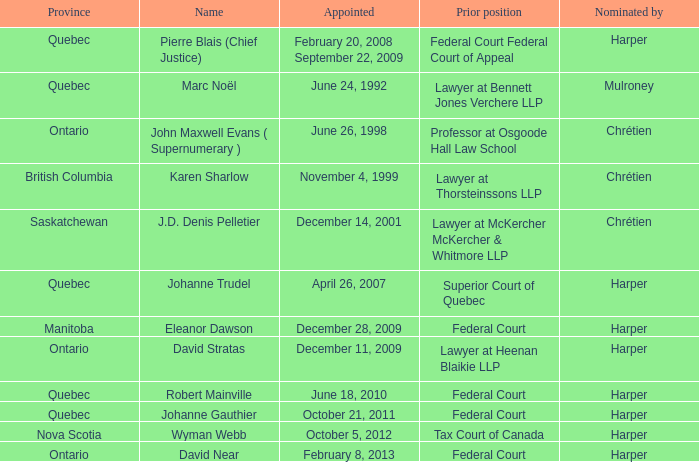What was the prior position held by Wyman Webb? Tax Court of Canada. 